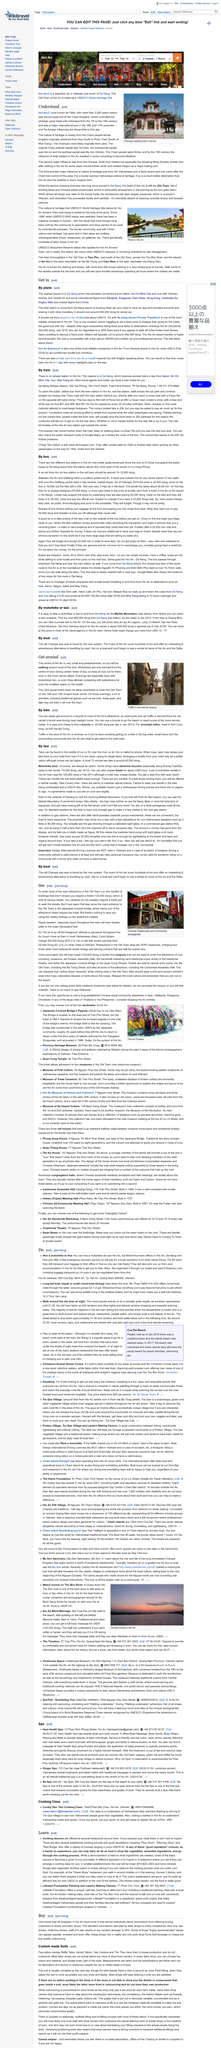Indicate a few pertinent items in this graphic. Some of the traditional games held all over the town are Bai choi, trong quan, and dap nieu. The use of motorbikes is prohibited in the center of town during certain times of the day. The city's government does not allow motorbikes to enter the Old Town on the 14th and 15th of each lunar month. 